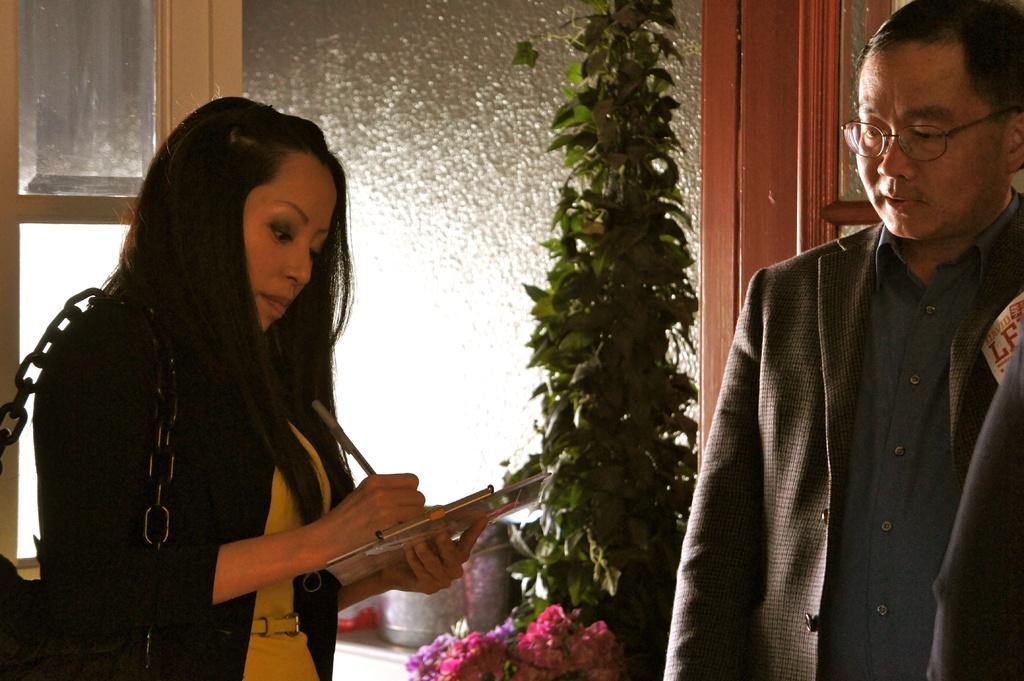Describe this image in one or two sentences. In this image I can see two people standing. The woman is wearing bag and holding pen,book. Back I can see a green leaves and glass windows. 